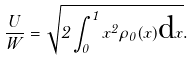Convert formula to latex. <formula><loc_0><loc_0><loc_500><loc_500>\frac { U } { W } = \sqrt { 2 \int _ { 0 } ^ { 1 } x ^ { 2 } \rho _ { 0 } ( x ) \text {d} x } .</formula> 